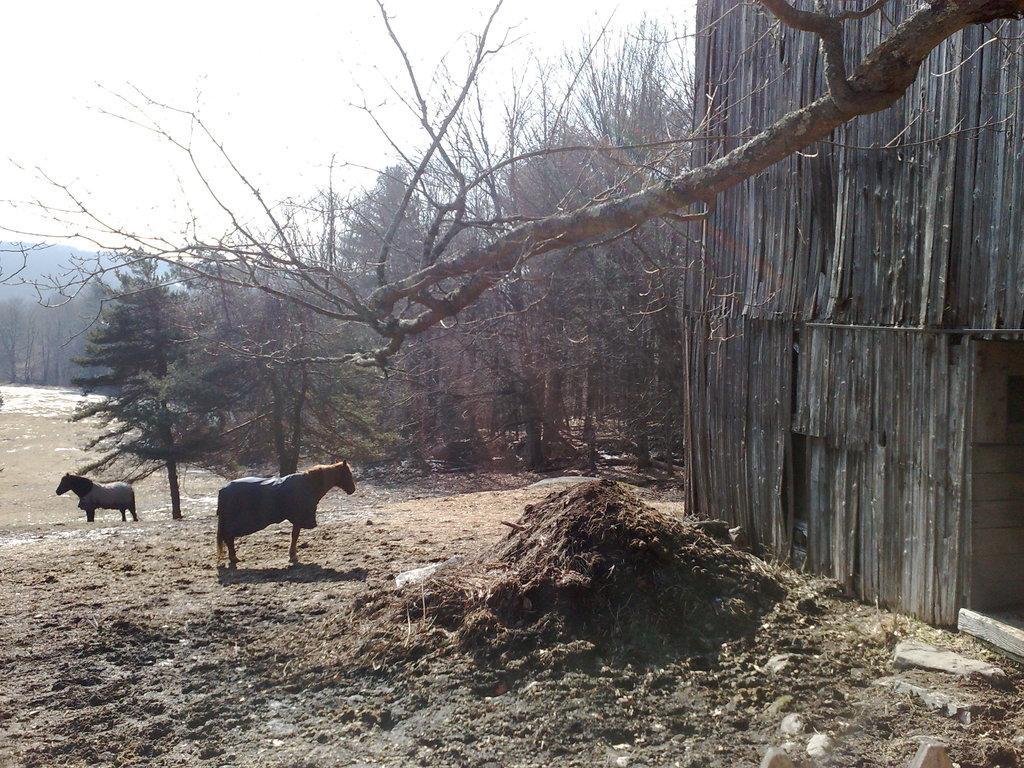Please provide a concise description of this image. In this picture we can see two horses in the ground. Behind we can see some trees. On the right corner there is a big wooden shed. 